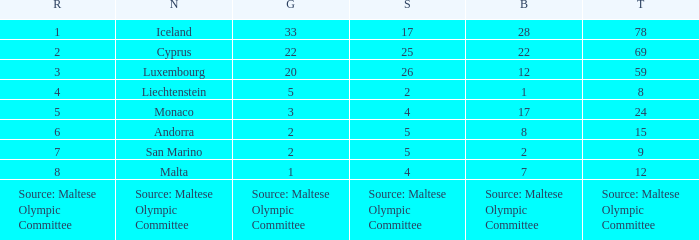What rank is the nation that has a bronze of source: Maltese Olympic Committee? Source: Maltese Olympic Committee. 